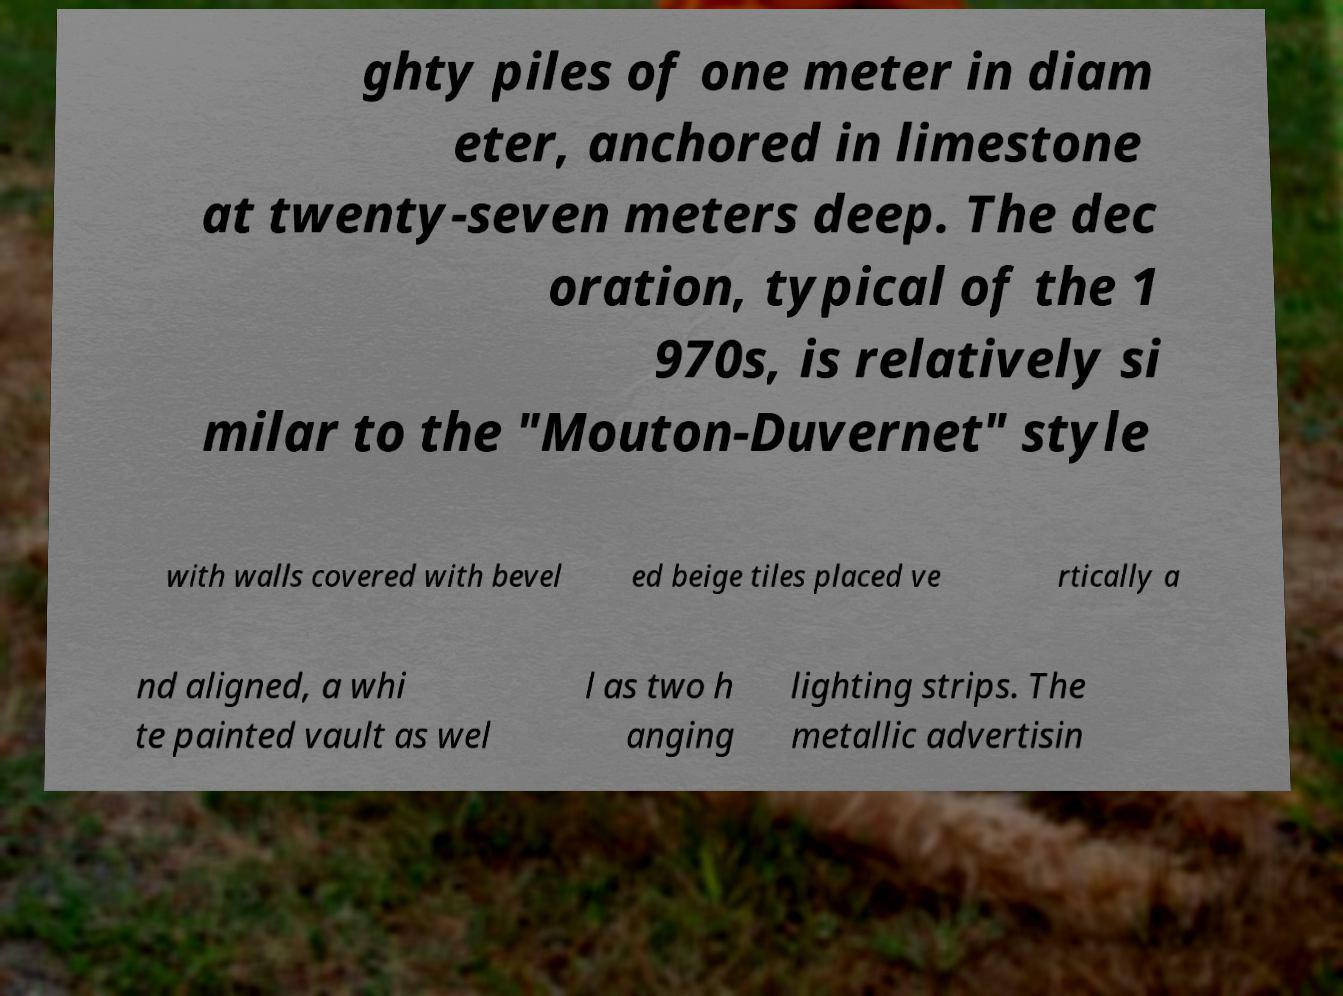For documentation purposes, I need the text within this image transcribed. Could you provide that? ghty piles of one meter in diam eter, anchored in limestone at twenty-seven meters deep. The dec oration, typical of the 1 970s, is relatively si milar to the "Mouton-Duvernet" style with walls covered with bevel ed beige tiles placed ve rtically a nd aligned, a whi te painted vault as wel l as two h anging lighting strips. The metallic advertisin 